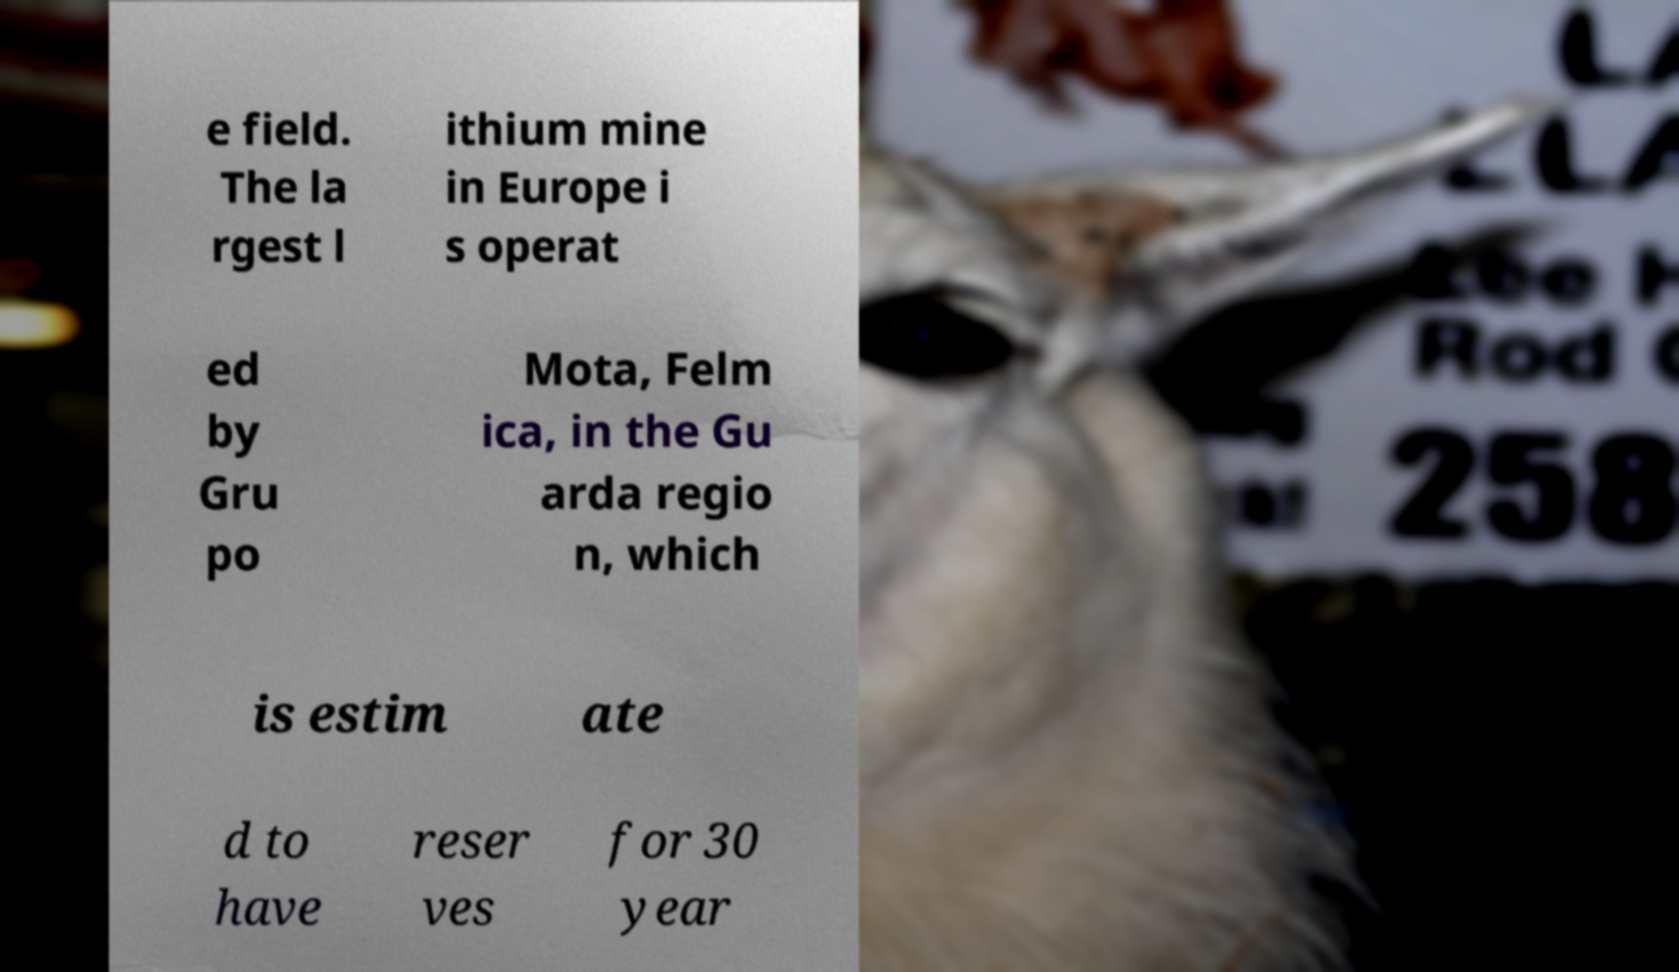Please identify and transcribe the text found in this image. e field. The la rgest l ithium mine in Europe i s operat ed by Gru po Mota, Felm ica, in the Gu arda regio n, which is estim ate d to have reser ves for 30 year 